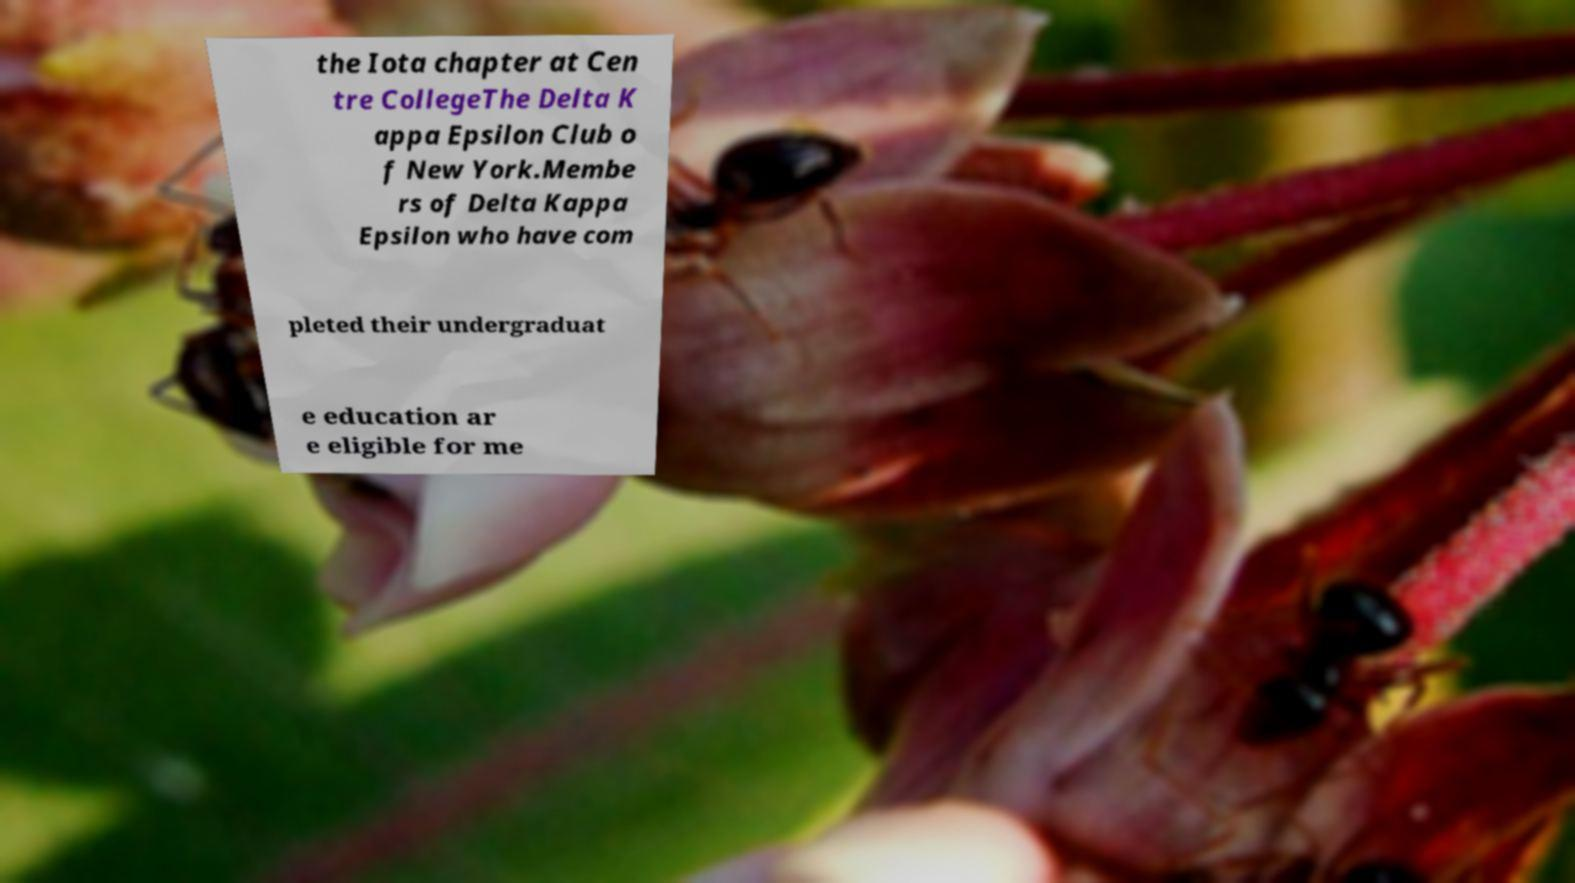There's text embedded in this image that I need extracted. Can you transcribe it verbatim? the Iota chapter at Cen tre CollegeThe Delta K appa Epsilon Club o f New York.Membe rs of Delta Kappa Epsilon who have com pleted their undergraduat e education ar e eligible for me 